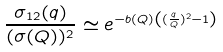<formula> <loc_0><loc_0><loc_500><loc_500>\frac { \sigma _ { 1 2 } ( q ) } { ( \sigma ( Q ) ) ^ { 2 } } \simeq e ^ { - b ( Q ) \left ( ( \frac { q } { Q } ) ^ { 2 } - 1 \right ) }</formula> 